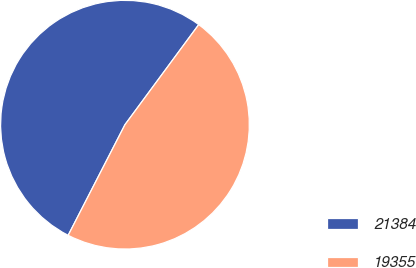<chart> <loc_0><loc_0><loc_500><loc_500><pie_chart><fcel>21384<fcel>19355<nl><fcel>52.56%<fcel>47.44%<nl></chart> 